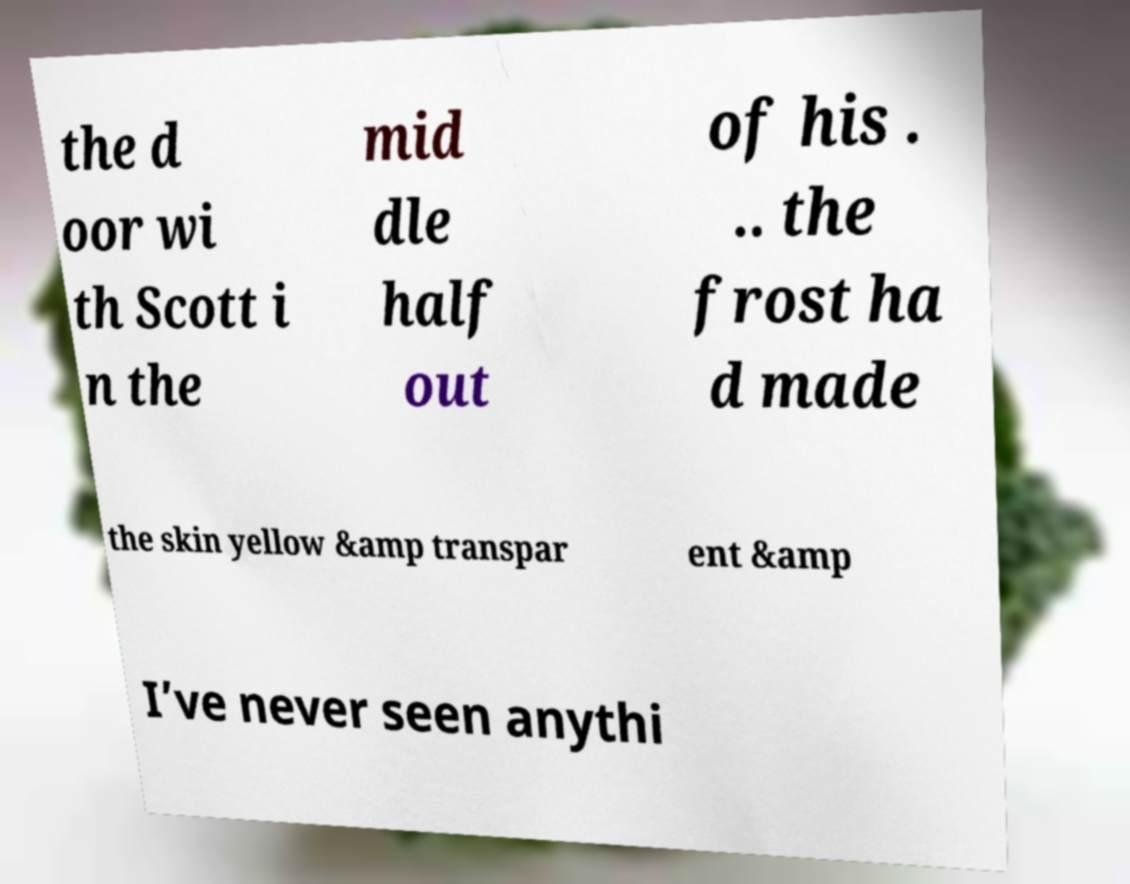Could you extract and type out the text from this image? the d oor wi th Scott i n the mid dle half out of his . .. the frost ha d made the skin yellow &amp transpar ent &amp I’ve never seen anythi 